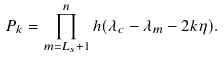<formula> <loc_0><loc_0><loc_500><loc_500>P _ { k } = \prod _ { m = L _ { s } + 1 } ^ { n } h ( \lambda _ { c } - \lambda _ { m } - 2 k \eta ) .</formula> 